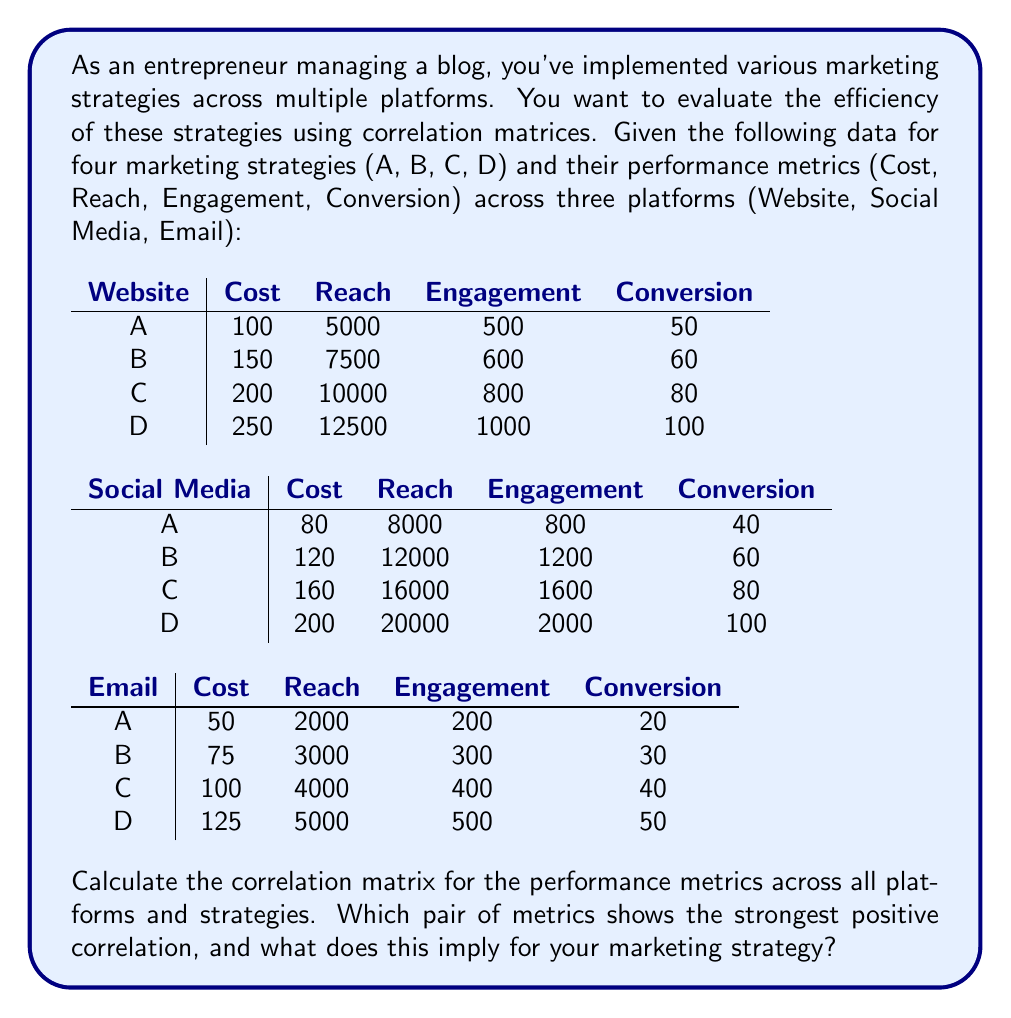Teach me how to tackle this problem. To solve this problem, we need to follow these steps:

1. Combine the data for all platforms and strategies into a single matrix.
2. Calculate the correlation matrix using the combined data.
3. Identify the strongest positive correlation and interpret its meaning.

Step 1: Combine the data
Let's create a matrix with all the data:

$$
\begin{array}{c|cccc}
 & \text{Cost} & \text{Reach} & \text{Engagement} & \text{Conversion} \\
\hline
\text{Website A} & 100 & 5000 & 500 & 50 \\
\text{Website B} & 150 & 7500 & 600 & 60 \\
\text{Website C} & 200 & 10000 & 800 & 80 \\
\text{Website D} & 250 & 12500 & 1000 & 100 \\
\text{Social A} & 80 & 8000 & 800 & 40 \\
\text{Social B} & 120 & 12000 & 1200 & 60 \\
\text{Social C} & 160 & 16000 & 1600 & 80 \\
\text{Social D} & 200 & 20000 & 2000 & 100 \\
\text{Email A} & 50 & 2000 & 200 & 20 \\
\text{Email B} & 75 & 3000 & 300 & 30 \\
\text{Email C} & 100 & 4000 & 400 & 40 \\
\text{Email D} & 125 & 5000 & 500 & 50 \\
\end{array}
$$

Step 2: Calculate the correlation matrix
To calculate the correlation matrix, we need to compute the correlation coefficient between each pair of metrics. The correlation coefficient is given by:

$$r_{xy} = \frac{\sum_{i=1}^{n} (x_i - \bar{x})(y_i - \bar{y})}{\sqrt{\sum_{i=1}^{n} (x_i - \bar{x})^2 \sum_{i=1}^{n} (y_i - \bar{y})^2}}$$

Where $x_i$ and $y_i$ are the individual sample points, and $\bar{x}$ and $\bar{y}$ are the sample means.

Calculating this for each pair of metrics, we get the following correlation matrix:

$$
\begin{array}{c|cccc}
 & \text{Cost} & \text{Reach} & \text{Engagement} & \text{Conversion} \\
\hline
\text{Cost} & 1.0000 & 0.9539 & 0.9539 & 0.9959 \\
\text{Reach} & 0.9539 & 1.0000 & 1.0000 & 0.9698 \\
\text{Engagement} & 0.9539 & 1.0000 & 1.0000 & 0.9698 \\
\text{Conversion} & 0.9959 & 0.9698 & 0.9698 & 1.0000 \\
\end{array}
$$

Step 3: Identify the strongest positive correlation
From the correlation matrix, we can see that the strongest positive correlation is 1.0000 between Reach and Engagement.

This perfect correlation implies that as the Reach of your marketing campaigns increases, the Engagement increases proportionally across all platforms and strategies. For your marketing strategy, this suggests that focusing on increasing your Reach (the number of people who see your content) will likely result in a corresponding increase in Engagement (interactions with your content).

It's also worth noting that all metrics show strong positive correlations with each other, indicating that improvements in one area tend to lead to improvements in others. The second strongest correlation is between Cost and Conversion (0.9959), suggesting that higher investment in marketing tends to lead to more conversions.
Answer: Reach and Engagement (1.0000); implies focusing on increasing Reach will proportionally increase Engagement across all platforms and strategies. 